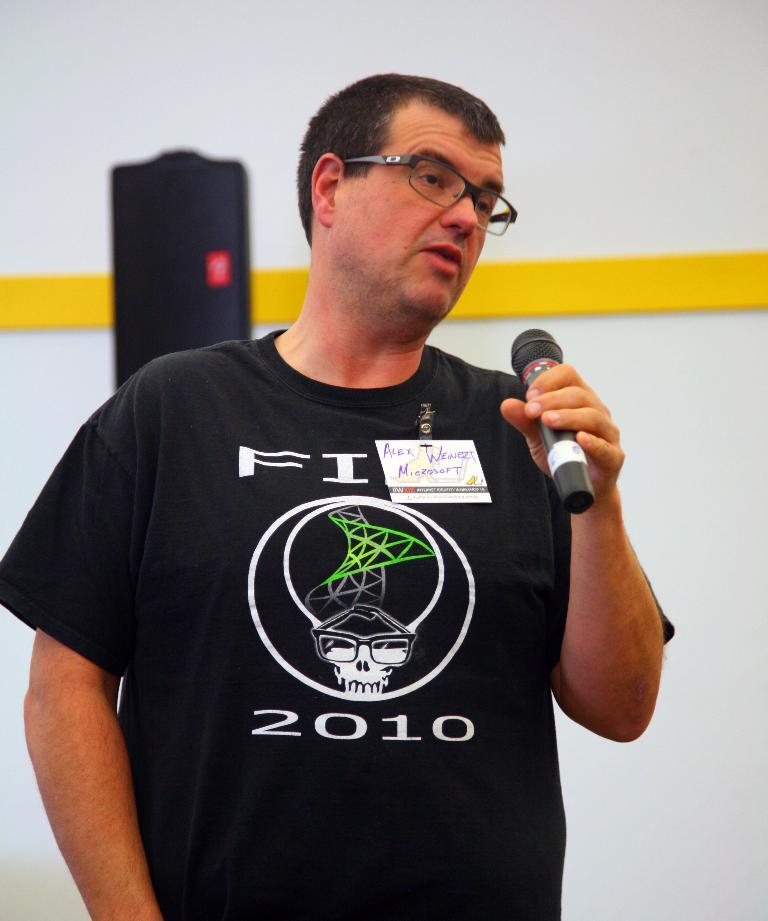What is the person in the image doing? The person is standing in the image. What can be seen on the person's face? The person is wearing spectacles. What object is the person holding? The person is holding a microphone. What is visible in the background of the image? There is a wall in the background of the image. How much salt is present on the person's breath in the image? There is no information about the person's breath or salt in the image, so it cannot be determined. 